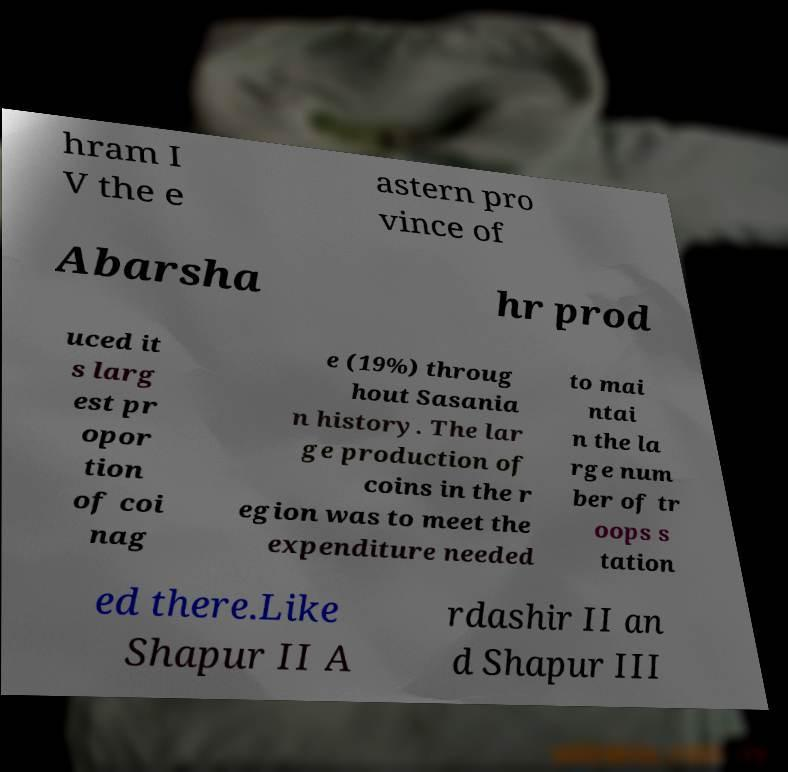I need the written content from this picture converted into text. Can you do that? hram I V the e astern pro vince of Abarsha hr prod uced it s larg est pr opor tion of coi nag e (19%) throug hout Sasania n history. The lar ge production of coins in the r egion was to meet the expenditure needed to mai ntai n the la rge num ber of tr oops s tation ed there.Like Shapur II A rdashir II an d Shapur III 